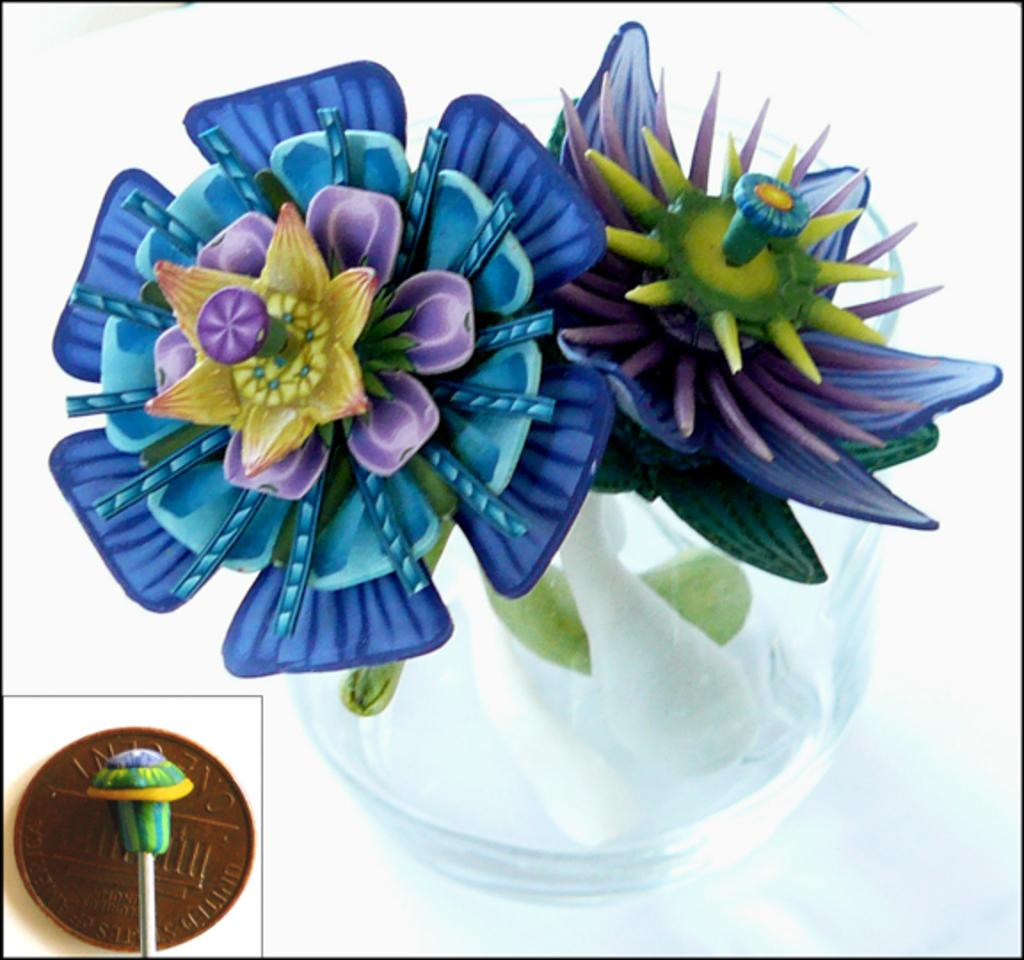What type of flower is in the pot in the image? There is an artificial flower in the pot in the image. Can you describe any other objects in the image? The facts provided only mention that there are objects in the image, but their specific nature is not detailed. Is the yak in the image reading a book? There is no yak or book present in the image. 